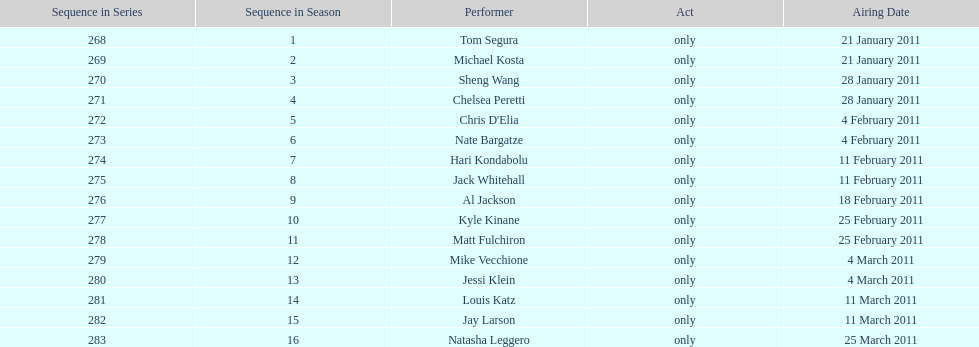Who appeared first tom segura or jay larson? Tom Segura. 